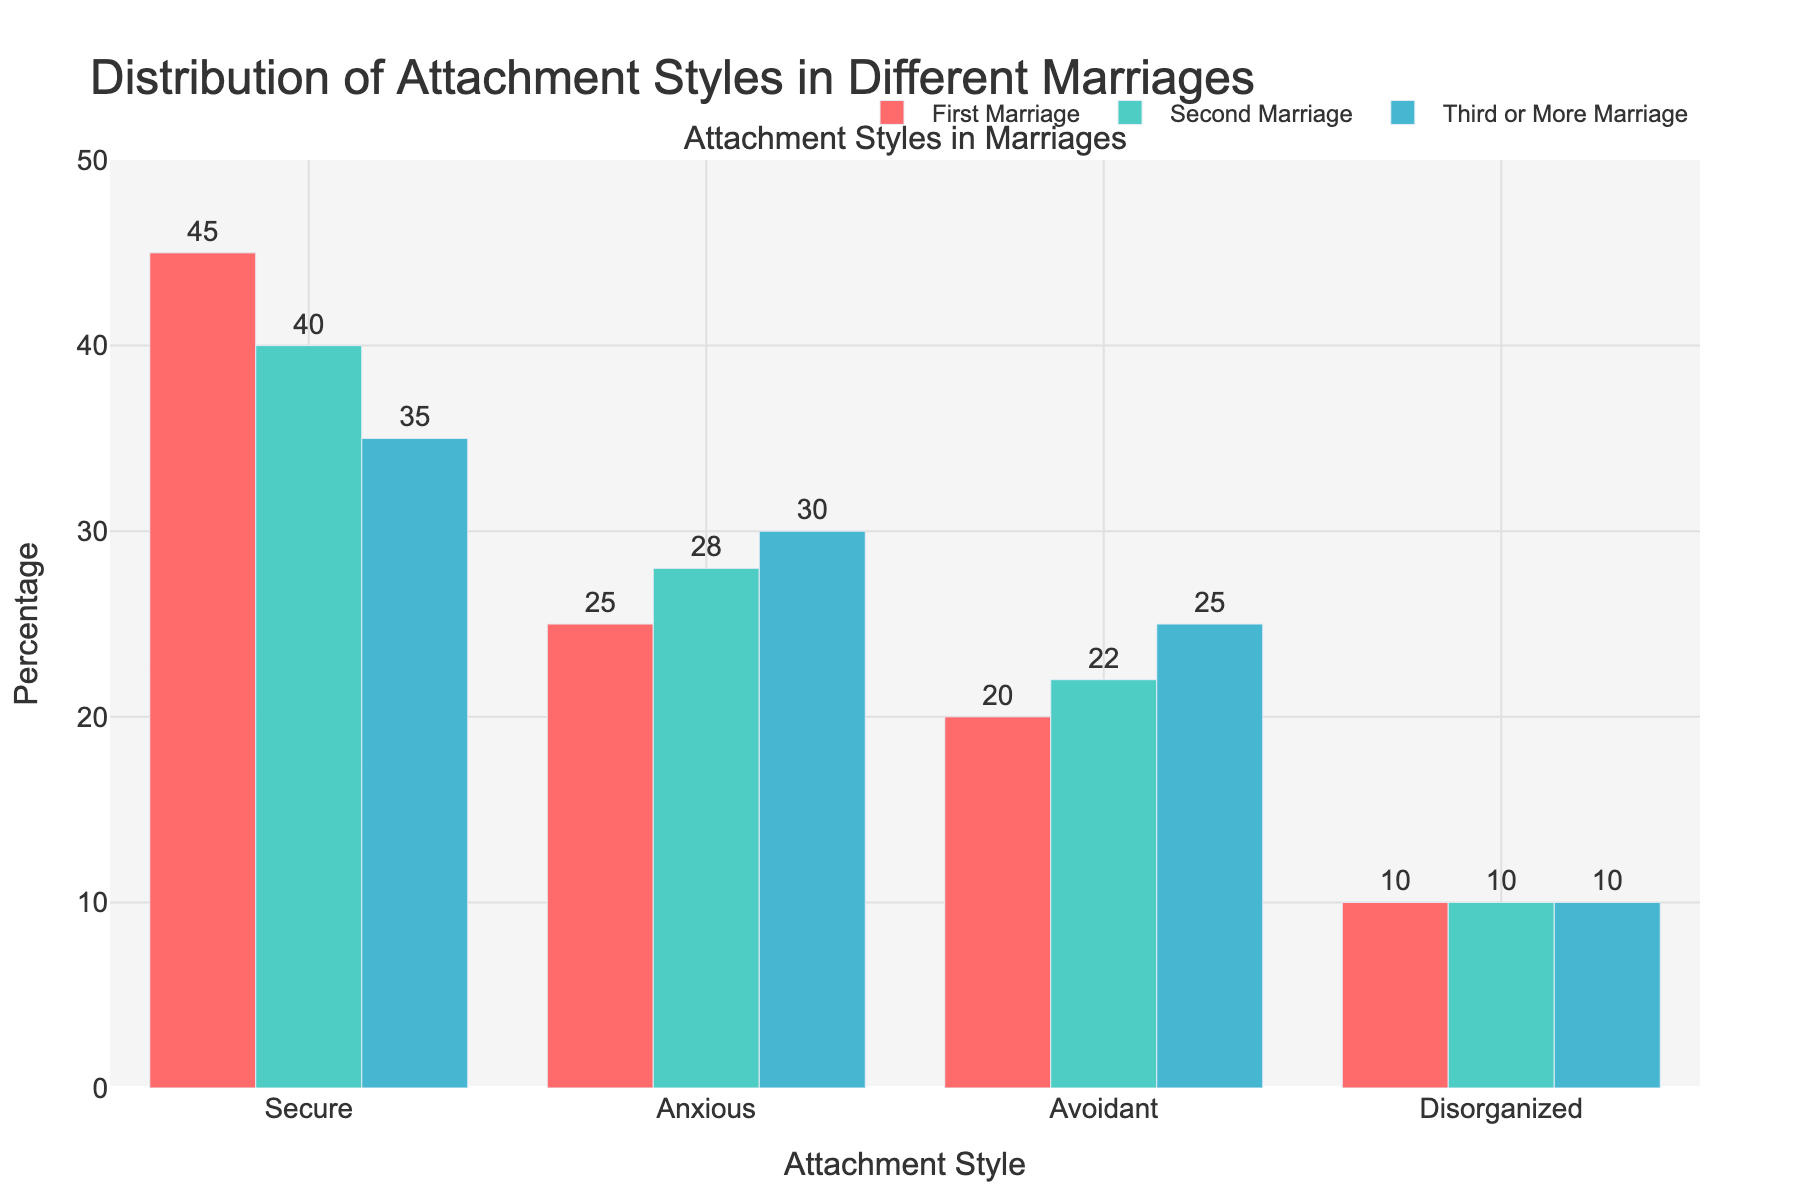What's the most common attachment style in first marriages? The highest bar in the group representing first marriages corresponds to the "Secure" attachment style, which is visually the tallest among the set.
Answer: Secure What is the difference in the percentage of couples with a secure attachment style between first and third or more marriages? The percentage of secure attachment in first marriages is 45%, and in third or more marriages, it is 35%. The difference is 45% - 35%.
Answer: 10% Which attachment style has the smallest variation across all types of marriages? The "Disorganized" attachment style shows a consistent percentage of 10% across first, second, and third or more marriages, indicating no variation.
Answer: Disorganized How does the percentage of avoidant attachment style in second marriages compare to first marriages? The percentage of avoidant attachment is 20% in first marriages and 22% in second marriages. Therefore, avoidant attachment is slightly higher in second marriages.
Answer: Second marriages have more What is the sum of the percentages of anxious attachment styles across all types of marriages? By adding the percentages of anxious attachment across all marriages: 25% (first) + 28% (second) + 30% (third or more) = 83%.
Answer: 83% Which attachment style shows the largest increase when comparing first to third or more marriages? To find the largest increase, compare the differences for each attachment style: Secure (35% - 45% = -10%), Anxious (30% - 25% = 5%), Avoidant (25% - 20% = 5%), Disorganized (10% - 10% = 0%). The Anxious and Avoidant styles both increase by 5%, which is the largest.
Answer: Anxious and Avoidant What percentage of couples in second marriages have an insecure attachment style (combining anxious, avoidant, and disorganized)? Adding the percentages of anxious, avoidant, and disorganized attachments in second marriages: 28% (anxious) + 22% (avoidant) + 10% (disorganized) = 60%.
Answer: 60% Is the percentage of secure attachment styles more in first marriages or third or more marriages? Comparing the percentages of secure attachment: 45% in first marriages and 35% in third or more marriages. First marriages have a higher percentage of secure attachment.
Answer: First marriages Are there any attachment styles for which the percentage remains constant across different marriages? The Disorganized attachment style has a constant percentage of 10% across first, second, and third or more marriages.
Answer: Yes Which attachment style in third or more marriages has the highest percentage? In third or more marriages, the "Secure" attachment style has the highest percentage at 35%, as indicated by the tallest bar.
Answer: Secure 